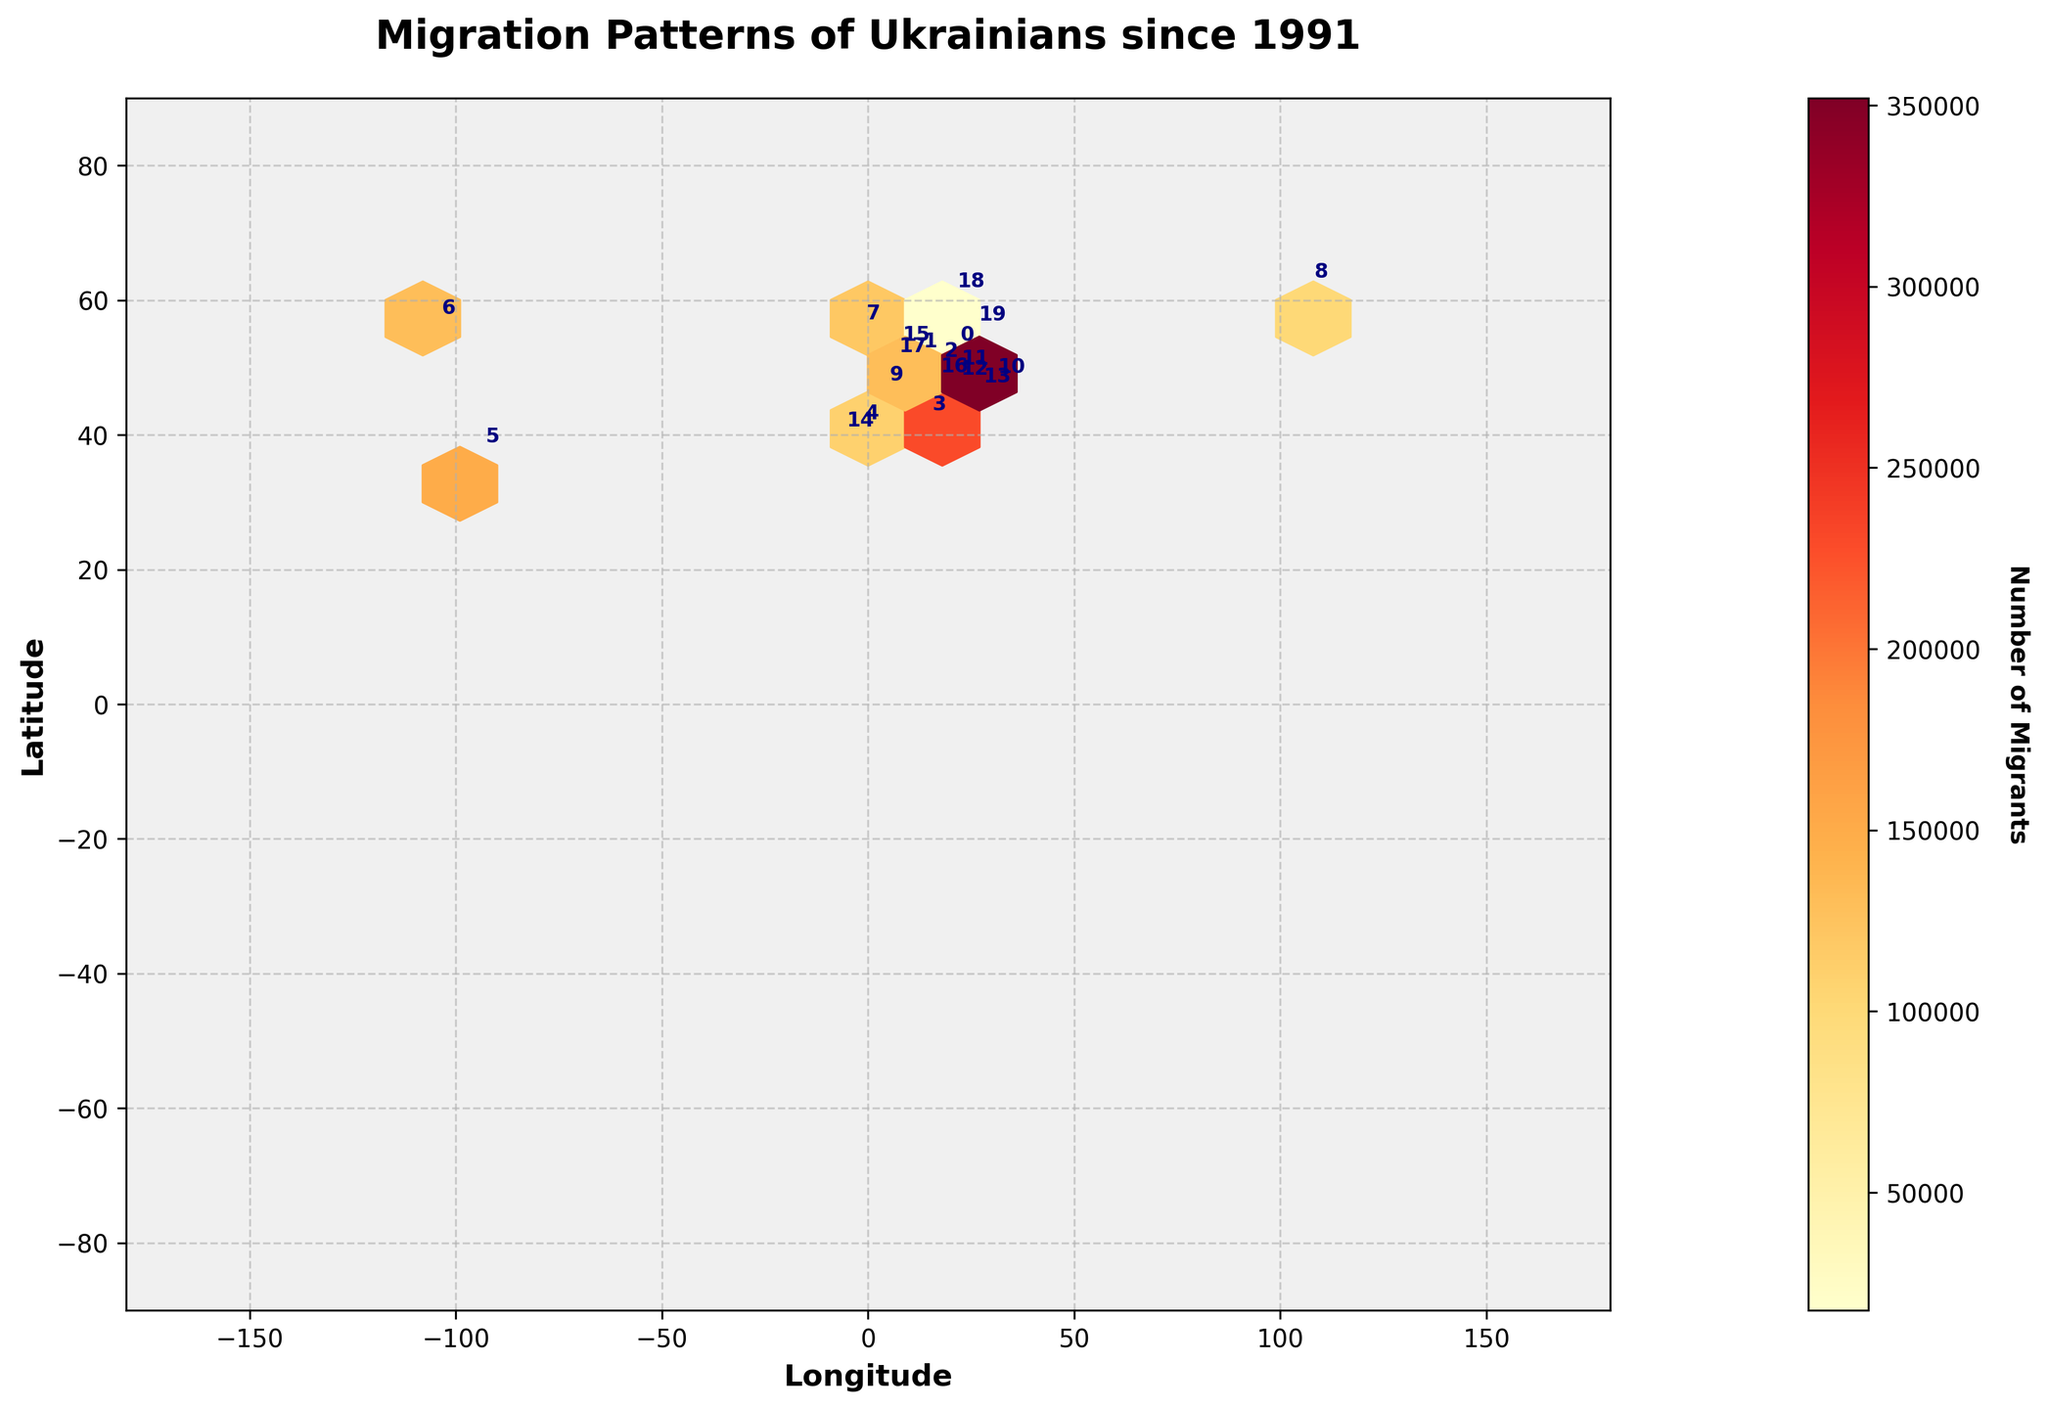what is the highest number of migrants shown in the plot? The highest number of migrants corresponds to the largest labeled number in the color bar. According to the data provided, it is 1,500,000 migrants in Poland.
Answer: 1,500,000 Which country has the second highest number of Ukrainian migrants after Poland? To find the second highest number of Ukrainian migrants, refer to the color bar and annotated numbers on the plot. Germany has the next highest number shown as 320,000 migrants.
Answer: Germany What's the total number of Ukrainian migrants in Germany, Czech Republic, and Italy? Sum the numbers of Ukrainian migrants for Germany (320,000), Czech Republic (280,000), and Italy (230,000). The calculation is 320,000 + 280,000 + 230,000 = 830,000.
Answer: 830,000 Compare the number of migrants in Canada and Spain. Which country has fewer Ukrainian migrants? Look at the annotated numbers on the plot for Canada (130,000) and Spain (180,000). Canada has fewer migrants than Spain.
Answer: Canada Among the Nordic countries listed (Sweden), how many Ukrainian migrants are there? Identify the label for Sweden’s migrants on the plot which is 20,000.
Answer: 20,000 Which region has a higher concentration of Ukrainian migrants: North America (US, Canada) or Southern Europe (Italy, Spain, Portugal)? Sum the migrants in the US (150,000) and Canada (130,000), which equals 150,000 + 130,000 = 280,000.
Sum the migrants in Italy (230,000), Spain (180,000), and Portugal (40,000), which equals 230,000 + 180,000 + 40,000 = 450,000.
Comparison: 450,000 > 280,000. Southern Europe has a higher concentration of Ukrainian migrants.
Answer: Southern Europe which two countries in Eastern Europe have almost equal numbers of Ukrainian migrants? From the plot annotations, Moldova has 80,000 and Slovakia has 70,000 migrants, showing relatively close numbers.
Answer: Moldova and Slovakia 